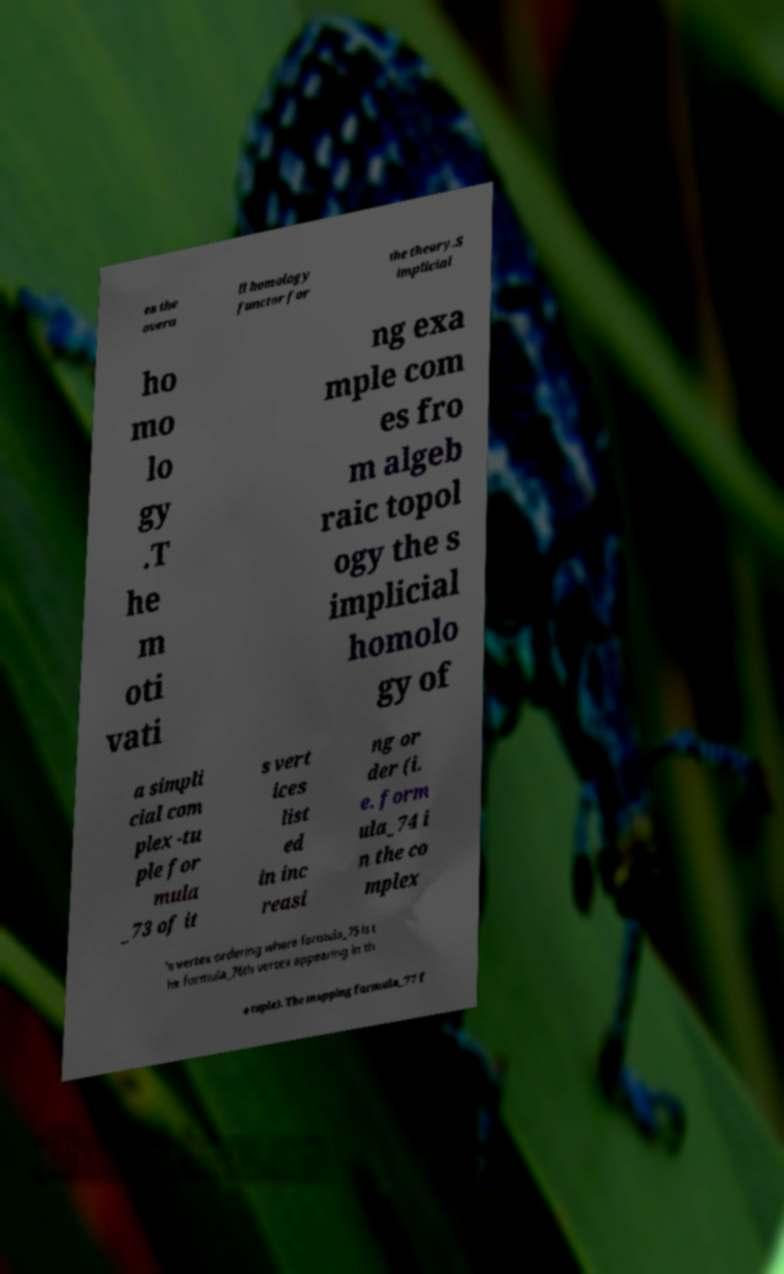Could you extract and type out the text from this image? es the overa ll homology functor for the theory.S implicial ho mo lo gy .T he m oti vati ng exa mple com es fro m algeb raic topol ogy the s implicial homolo gy of a simpli cial com plex -tu ple for mula _73 of it s vert ices list ed in inc reasi ng or der (i. e. form ula_74 i n the co mplex 's vertex ordering where formula_75 is t he formula_76th vertex appearing in th e tuple). The mapping formula_77 f 